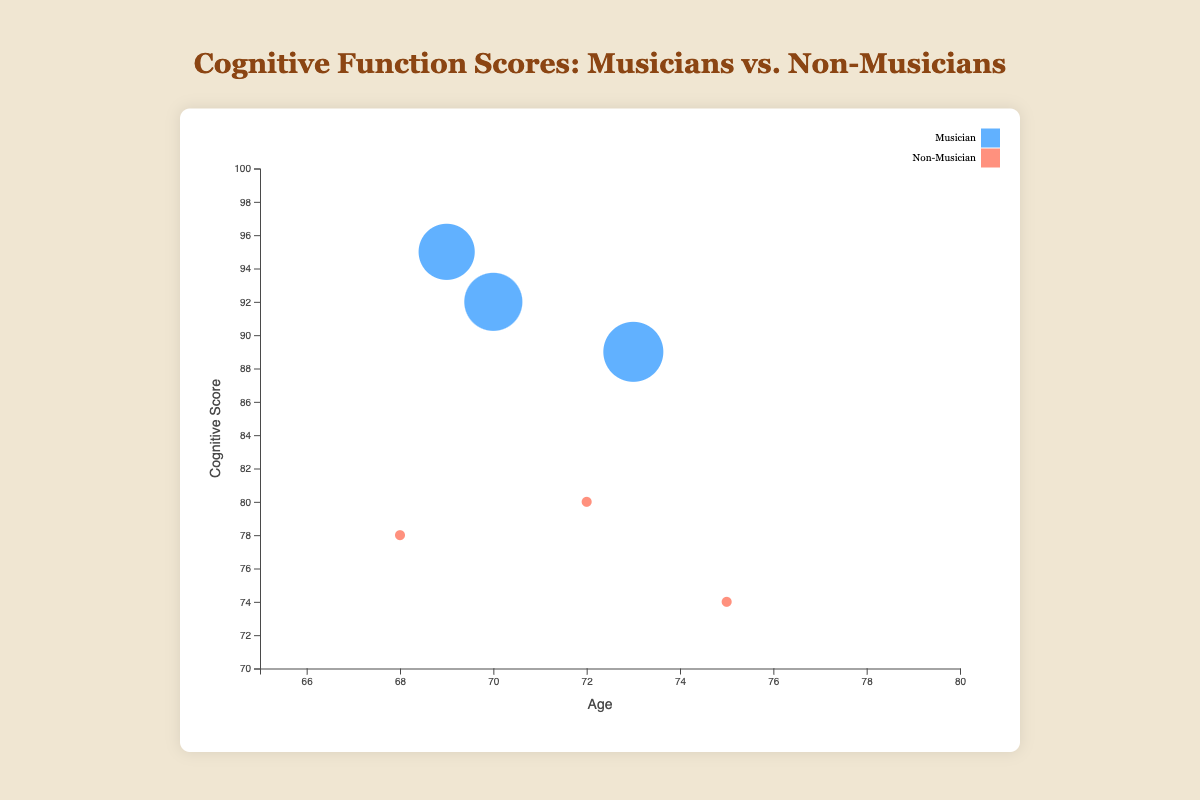What are the groups represented in the plot? The legend in the figure shows two color representations: blue for "Musician" and red for "Non-Musician".
Answer: Musician and Non-Musician Which axis represents Cognitive Scores? The y-axis has the label "Cognitive Score", indicating it represents cognitive scores.
Answer: y-axis What is the age range of the individuals in the plot? The x-axis shows the range and the labels from 65 to 80, indicating the ages of individuals.
Answer: 65 to 80 How many individuals are represented in the plot? There are six circles (bubbles) in the plot, each representing one individual.
Answer: Six Which group has the highest cognitive score, and what is the score? The highest bubble on the y-axis represents Charles Brown from the "Musician" group with a cognitive score of 95.
Answer: Musician, 95 Which individual has the lowest cognitive score and what is their group? The lowest bubble on the y-axis represents Eleanor Rigby from the "Non-Musician" group, with a cognitive score of 74.
Answer: Eleanor Rigby, Non-Musician What is the cognitive score difference between the highest scoring musician and the highest scoring non-musician? Charles Brown (Musician) has a score of 95, and Martha Jones (Non-Musician) has a score of 80. The difference is 95 - 80 = 15.
Answer: 15 Are there any individuals with the same or similar cognitive scores, and who are they? John Doe and Tom Harris, both musicians, have similar cognitive scores of 92 and 89, respectively.
Answer: John Doe and Tom Harris Considering the bubble sizes, which musician has the most years of experience? Charles Brown's bubble is the largest among musicians, indicating he has the most years of experience (48 years).
Answer: Charles Brown Is there a correlation between years of experience and cognitive score among musicians based on the plot? Musicians with more years of experience (larger bubbles) tend to have higher cognitive scores, indicating a potential positive correlation.
Answer: Positive correlation 